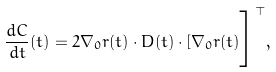Convert formula to latex. <formula><loc_0><loc_0><loc_500><loc_500>\frac { d { C } } { d t } ( t ) = 2 { \mathbf \nabla } _ { 0 } { r } ( t ) \cdot { D } ( t ) \cdot [ { \mathbf \nabla } _ { 0 } { r } ( t ) \Big ] ^ { \top } ,</formula> 